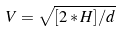Convert formula to latex. <formula><loc_0><loc_0><loc_500><loc_500>V = \sqrt { [ 2 * H ] / d }</formula> 